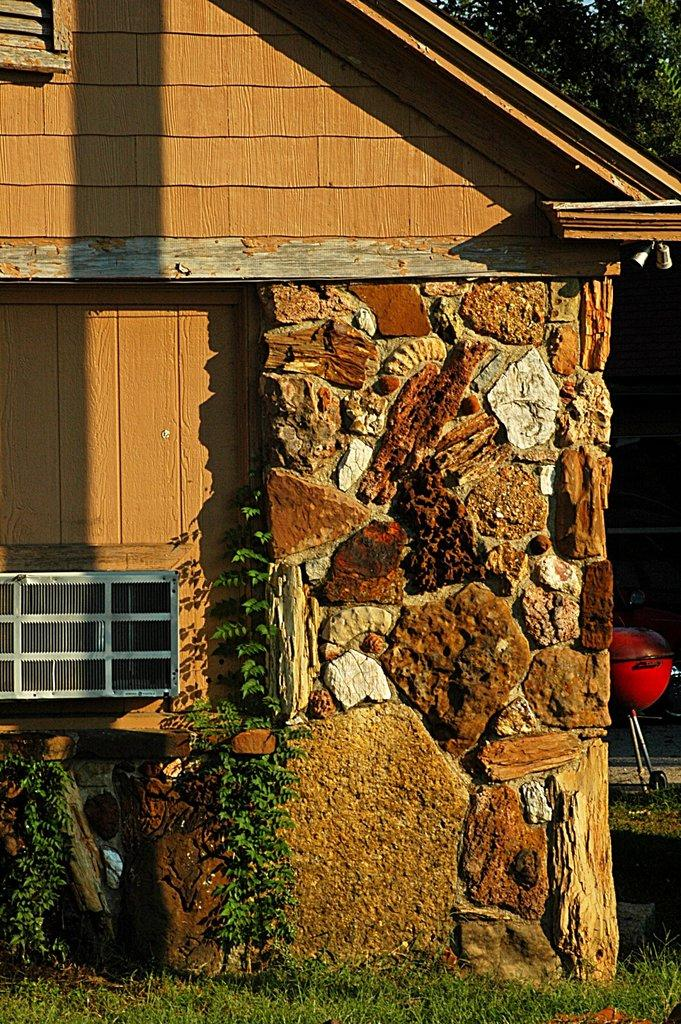What type of structure can be seen in the image? There is a shed present in the image. What type of vegetation is visible in the image? There is grass and plants visible in the image. What can be seen in the background of the image? There is a tree and a charcoal bbq visible in the background of the image. What type of experience can be seen on the plate in the image? There is no plate present in the image, so it is not possible to determine what type of experience might be seen on it. 